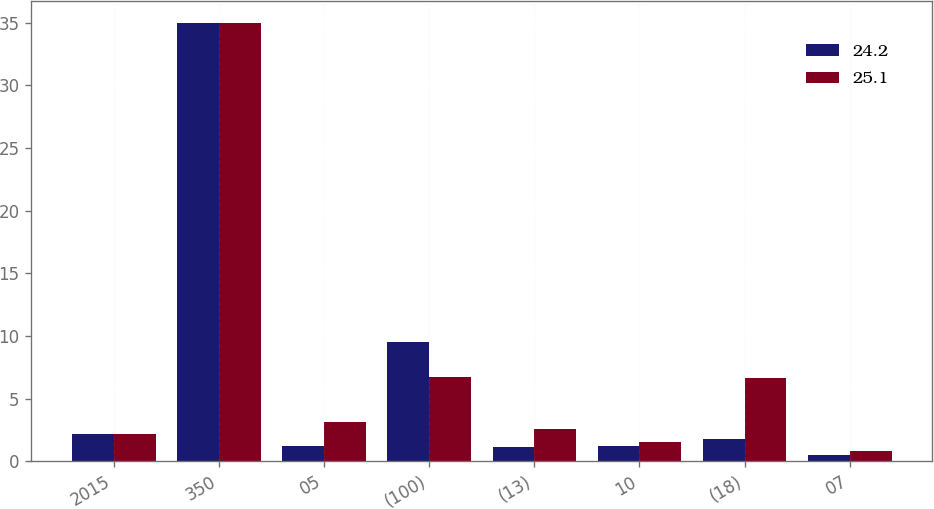Convert chart. <chart><loc_0><loc_0><loc_500><loc_500><stacked_bar_chart><ecel><fcel>2015<fcel>350<fcel>05<fcel>(100)<fcel>(13)<fcel>10<fcel>(18)<fcel>07<nl><fcel>24.2<fcel>2.2<fcel>35<fcel>1.2<fcel>9.5<fcel>1.1<fcel>1.2<fcel>1.8<fcel>0.5<nl><fcel>25.1<fcel>2.2<fcel>35<fcel>3.1<fcel>6.7<fcel>2.6<fcel>1.5<fcel>6.6<fcel>0.8<nl></chart> 